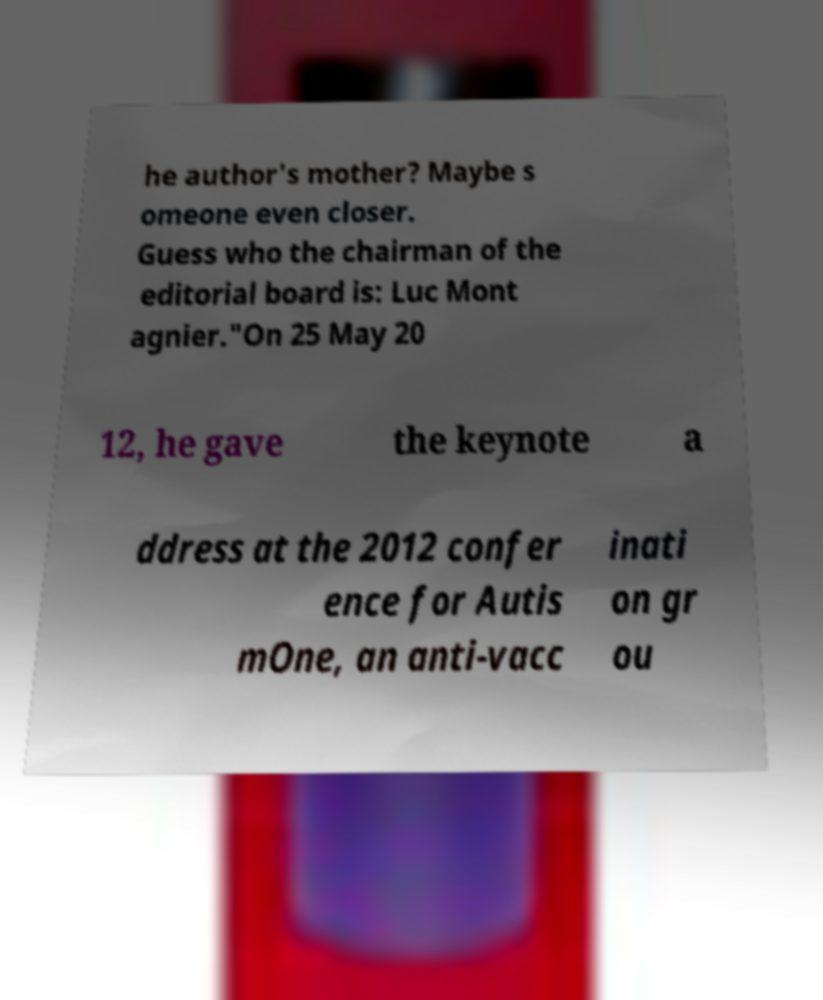Could you extract and type out the text from this image? he author's mother? Maybe s omeone even closer. Guess who the chairman of the editorial board is: Luc Mont agnier."On 25 May 20 12, he gave the keynote a ddress at the 2012 confer ence for Autis mOne, an anti-vacc inati on gr ou 